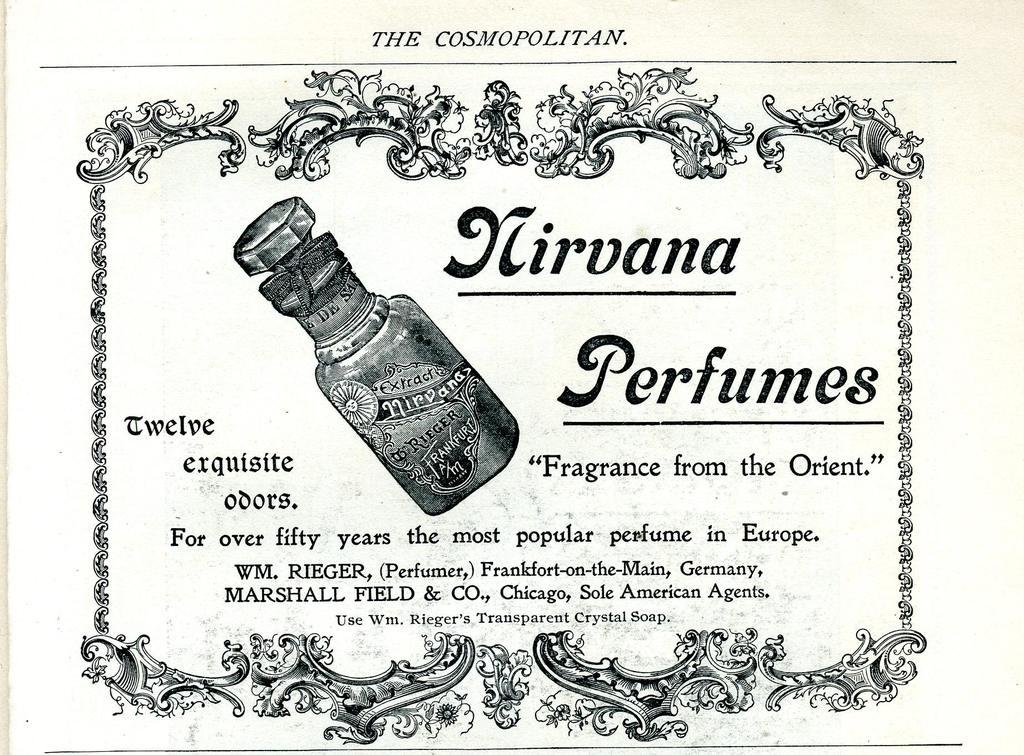<image>
Offer a succinct explanation of the picture presented. Nirvana Perfumes Fragrance from the Orient from the Cosmopolitan. 